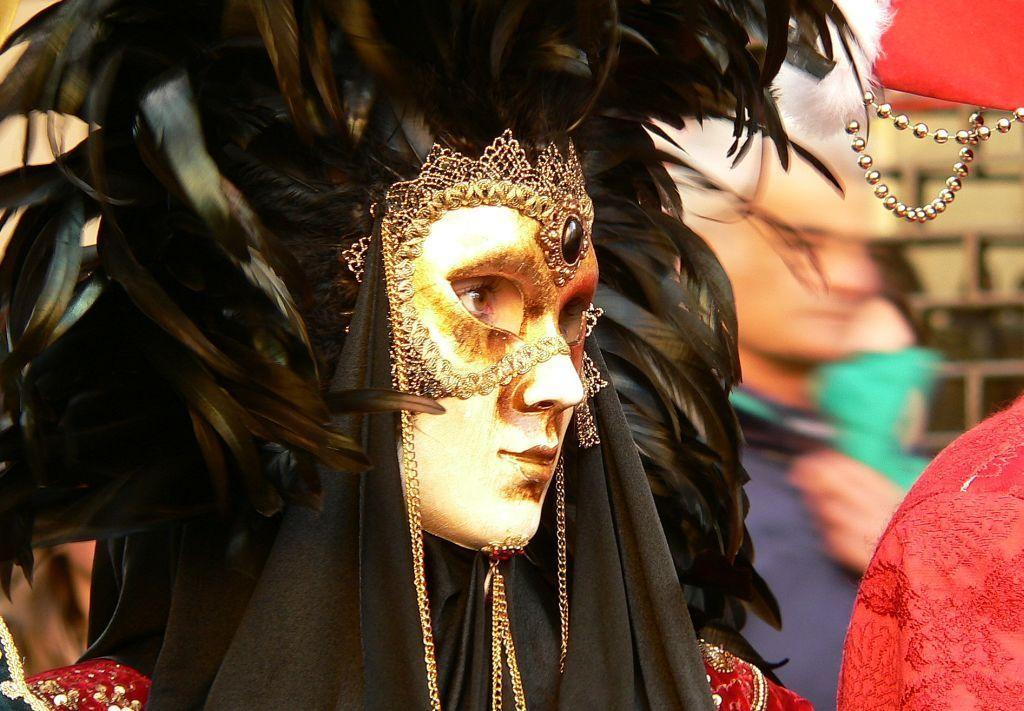Who or what can be seen in the image? There are people in the image. What are the people wearing? The people are wearing different costumes. What can be seen in the background of the image? There is a wall in the background of the image. Where is the playground located in the image? There is no playground present in the image. What type of bike can be seen in the image? There is no bike present in the image. 